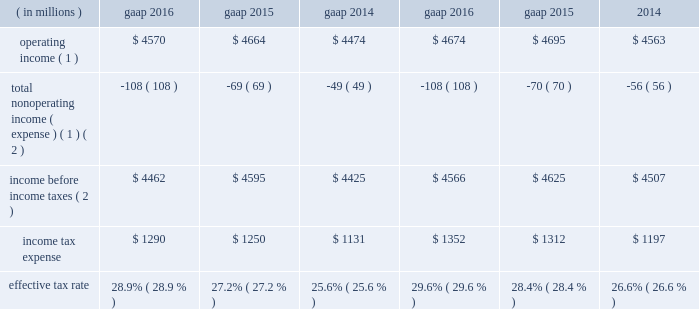2016 compared with 2015 net gains on investments of $ 57 million in 2016 decreased $ 52 million from 2015 due to lower net gains in 2016 .
Net gains on investments in 2015 included a $ 40 million gain related to the bkca acquisition and a $ 35 million unrealized gain on a private equity investment .
Interest and dividend income increased $ 14 million from 2015 primarily due to higher dividend income in 2016 .
2015 compared with 2014 net gains on investments of $ 109 million in 2015 decreased $ 45 million from 2014 due to lower net gains in 2015 .
Net gains on investments in 2015 included a $ 40 million gain related to the bkca acquisition and a $ 35 million unrealized gain on a private equity investment .
Net gains on investments in 2014 included the positive impact of the monetization of a nonstrategic , opportunistic private equity investment .
Interest expense decreased $ 28 million from 2014 primarily due to repayments of long-term borrowings in the fourth quarter of 2014 .
Income tax expense .
( 1 ) see non-gaap financial measures for further information on and reconciliation of as adjusted items .
( 2 ) net of net income ( loss ) attributable to nci .
The company 2019s tax rate is affected by tax rates in foreign jurisdictions and the relative amount of income earned in those jurisdictions , which the company expects to be fairly consistent in the near term .
The significant foreign jurisdictions that have lower statutory tax rates than the u.s .
Federal statutory rate of 35% ( 35 % ) include the united kingdom , channel islands , ireland and canada .
U.s .
Income taxes were not provided for certain undistributed foreign earnings intended to be indefinitely reinvested outside the united states .
2016 .
Income tax expense ( gaap ) reflected : 2022 a net noncash benefit of $ 30 million , primarily associated with the revaluation of certain deferred income tax liabilities ; and 2022 a benefit from $ 65 million of nonrecurring items , including the resolution of certain outstanding tax matters .
The as adjusted effective tax rate of 29.6% ( 29.6 % ) for 2016 excluded the net noncash benefit of $ 30 million mentioned above , as it will not have a cash flow impact and to ensure comparability among periods presented .
2015 .
Income tax expense ( gaap ) reflected : 2022 a net noncash benefit of $ 54 million , primarily associated with the revaluation of certain deferred income tax liabilities ; and 2022 a benefit from $ 75 million of nonrecurring items , primarily due to the realization of losses from changes in the company 2019s organizational tax structure and the resolution of certain outstanding tax matters .
The as adjusted effective tax rate of 28.4% ( 28.4 % ) for 2015 excluded the net noncash benefit of $ 54 million mentioned above , as it will not have a cash flow impact and to ensure comparability among periods presented .
2014 .
Income tax expense ( gaap ) reflected : 2022 a $ 94 million tax benefit , primarily due to the resolution of certain outstanding tax matters related to the acquisition of bgi , including the previously mentioned $ 50 million tax benefit ( see executive summary for more information ) ; 2022 a $ 73 million net tax benefit related to several favorable nonrecurring items ; and 2022 a net noncash benefit of $ 9 million associated with the revaluation of deferred income tax liabilities .
The as adjusted effective tax rate of 26.6% ( 26.6 % ) for 2014 excluded the $ 9 million net noncash benefit as it will not have a cash flow impact and to ensure comparability among periods presented and the $ 50 million tax benefit mentioned above .
The $ 50 million general and administrative expense and $ 50 million tax benefit have been excluded from as adjusted results as there is no impact on blackrock 2019s book value .
Balance sheet overview as adjusted balance sheet the following table presents a reconciliation of the consolidated statement of financial condition presented on a gaap basis to the consolidated statement of financial condition , excluding the impact of separate account assets and separate account collateral held under securities lending agreements ( directly related to lending separate account securities ) and separate account liabilities and separate account collateral liabilities under securities lending agreements and consolidated sponsored investment funds , including consolidated vies .
The company presents the as adjusted balance sheet as additional information to enable investors to exclude certain .
What is the percent change in effective tax rate from from 2015 to 2016? 
Computations: (28.9% - 27.2%)
Answer: 0.017. 2016 compared with 2015 net gains on investments of $ 57 million in 2016 decreased $ 52 million from 2015 due to lower net gains in 2016 .
Net gains on investments in 2015 included a $ 40 million gain related to the bkca acquisition and a $ 35 million unrealized gain on a private equity investment .
Interest and dividend income increased $ 14 million from 2015 primarily due to higher dividend income in 2016 .
2015 compared with 2014 net gains on investments of $ 109 million in 2015 decreased $ 45 million from 2014 due to lower net gains in 2015 .
Net gains on investments in 2015 included a $ 40 million gain related to the bkca acquisition and a $ 35 million unrealized gain on a private equity investment .
Net gains on investments in 2014 included the positive impact of the monetization of a nonstrategic , opportunistic private equity investment .
Interest expense decreased $ 28 million from 2014 primarily due to repayments of long-term borrowings in the fourth quarter of 2014 .
Income tax expense .
( 1 ) see non-gaap financial measures for further information on and reconciliation of as adjusted items .
( 2 ) net of net income ( loss ) attributable to nci .
The company 2019s tax rate is affected by tax rates in foreign jurisdictions and the relative amount of income earned in those jurisdictions , which the company expects to be fairly consistent in the near term .
The significant foreign jurisdictions that have lower statutory tax rates than the u.s .
Federal statutory rate of 35% ( 35 % ) include the united kingdom , channel islands , ireland and canada .
U.s .
Income taxes were not provided for certain undistributed foreign earnings intended to be indefinitely reinvested outside the united states .
2016 .
Income tax expense ( gaap ) reflected : 2022 a net noncash benefit of $ 30 million , primarily associated with the revaluation of certain deferred income tax liabilities ; and 2022 a benefit from $ 65 million of nonrecurring items , including the resolution of certain outstanding tax matters .
The as adjusted effective tax rate of 29.6% ( 29.6 % ) for 2016 excluded the net noncash benefit of $ 30 million mentioned above , as it will not have a cash flow impact and to ensure comparability among periods presented .
2015 .
Income tax expense ( gaap ) reflected : 2022 a net noncash benefit of $ 54 million , primarily associated with the revaluation of certain deferred income tax liabilities ; and 2022 a benefit from $ 75 million of nonrecurring items , primarily due to the realization of losses from changes in the company 2019s organizational tax structure and the resolution of certain outstanding tax matters .
The as adjusted effective tax rate of 28.4% ( 28.4 % ) for 2015 excluded the net noncash benefit of $ 54 million mentioned above , as it will not have a cash flow impact and to ensure comparability among periods presented .
2014 .
Income tax expense ( gaap ) reflected : 2022 a $ 94 million tax benefit , primarily due to the resolution of certain outstanding tax matters related to the acquisition of bgi , including the previously mentioned $ 50 million tax benefit ( see executive summary for more information ) ; 2022 a $ 73 million net tax benefit related to several favorable nonrecurring items ; and 2022 a net noncash benefit of $ 9 million associated with the revaluation of deferred income tax liabilities .
The as adjusted effective tax rate of 26.6% ( 26.6 % ) for 2014 excluded the $ 9 million net noncash benefit as it will not have a cash flow impact and to ensure comparability among periods presented and the $ 50 million tax benefit mentioned above .
The $ 50 million general and administrative expense and $ 50 million tax benefit have been excluded from as adjusted results as there is no impact on blackrock 2019s book value .
Balance sheet overview as adjusted balance sheet the following table presents a reconciliation of the consolidated statement of financial condition presented on a gaap basis to the consolidated statement of financial condition , excluding the impact of separate account assets and separate account collateral held under securities lending agreements ( directly related to lending separate account securities ) and separate account liabilities and separate account collateral liabilities under securities lending agreements and consolidated sponsored investment funds , including consolidated vies .
The company presents the as adjusted balance sheet as additional information to enable investors to exclude certain .
What is the growth rate in operating income from 2015 to 2016? 
Computations: ((4570 - 4664) / 4664)
Answer: -0.02015. 2016 compared with 2015 net gains on investments of $ 57 million in 2016 decreased $ 52 million from 2015 due to lower net gains in 2016 .
Net gains on investments in 2015 included a $ 40 million gain related to the bkca acquisition and a $ 35 million unrealized gain on a private equity investment .
Interest and dividend income increased $ 14 million from 2015 primarily due to higher dividend income in 2016 .
2015 compared with 2014 net gains on investments of $ 109 million in 2015 decreased $ 45 million from 2014 due to lower net gains in 2015 .
Net gains on investments in 2015 included a $ 40 million gain related to the bkca acquisition and a $ 35 million unrealized gain on a private equity investment .
Net gains on investments in 2014 included the positive impact of the monetization of a nonstrategic , opportunistic private equity investment .
Interest expense decreased $ 28 million from 2014 primarily due to repayments of long-term borrowings in the fourth quarter of 2014 .
Income tax expense .
( 1 ) see non-gaap financial measures for further information on and reconciliation of as adjusted items .
( 2 ) net of net income ( loss ) attributable to nci .
The company 2019s tax rate is affected by tax rates in foreign jurisdictions and the relative amount of income earned in those jurisdictions , which the company expects to be fairly consistent in the near term .
The significant foreign jurisdictions that have lower statutory tax rates than the u.s .
Federal statutory rate of 35% ( 35 % ) include the united kingdom , channel islands , ireland and canada .
U.s .
Income taxes were not provided for certain undistributed foreign earnings intended to be indefinitely reinvested outside the united states .
2016 .
Income tax expense ( gaap ) reflected : 2022 a net noncash benefit of $ 30 million , primarily associated with the revaluation of certain deferred income tax liabilities ; and 2022 a benefit from $ 65 million of nonrecurring items , including the resolution of certain outstanding tax matters .
The as adjusted effective tax rate of 29.6% ( 29.6 % ) for 2016 excluded the net noncash benefit of $ 30 million mentioned above , as it will not have a cash flow impact and to ensure comparability among periods presented .
2015 .
Income tax expense ( gaap ) reflected : 2022 a net noncash benefit of $ 54 million , primarily associated with the revaluation of certain deferred income tax liabilities ; and 2022 a benefit from $ 75 million of nonrecurring items , primarily due to the realization of losses from changes in the company 2019s organizational tax structure and the resolution of certain outstanding tax matters .
The as adjusted effective tax rate of 28.4% ( 28.4 % ) for 2015 excluded the net noncash benefit of $ 54 million mentioned above , as it will not have a cash flow impact and to ensure comparability among periods presented .
2014 .
Income tax expense ( gaap ) reflected : 2022 a $ 94 million tax benefit , primarily due to the resolution of certain outstanding tax matters related to the acquisition of bgi , including the previously mentioned $ 50 million tax benefit ( see executive summary for more information ) ; 2022 a $ 73 million net tax benefit related to several favorable nonrecurring items ; and 2022 a net noncash benefit of $ 9 million associated with the revaluation of deferred income tax liabilities .
The as adjusted effective tax rate of 26.6% ( 26.6 % ) for 2014 excluded the $ 9 million net noncash benefit as it will not have a cash flow impact and to ensure comparability among periods presented and the $ 50 million tax benefit mentioned above .
The $ 50 million general and administrative expense and $ 50 million tax benefit have been excluded from as adjusted results as there is no impact on blackrock 2019s book value .
Balance sheet overview as adjusted balance sheet the following table presents a reconciliation of the consolidated statement of financial condition presented on a gaap basis to the consolidated statement of financial condition , excluding the impact of separate account assets and separate account collateral held under securities lending agreements ( directly related to lending separate account securities ) and separate account liabilities and separate account collateral liabilities under securities lending agreements and consolidated sponsored investment funds , including consolidated vies .
The company presents the as adjusted balance sheet as additional information to enable investors to exclude certain .
What is the growth rate in operating income from 2014 to 2015? 
Computations: ((4664 - 4474) / 4474)
Answer: 0.04247. 